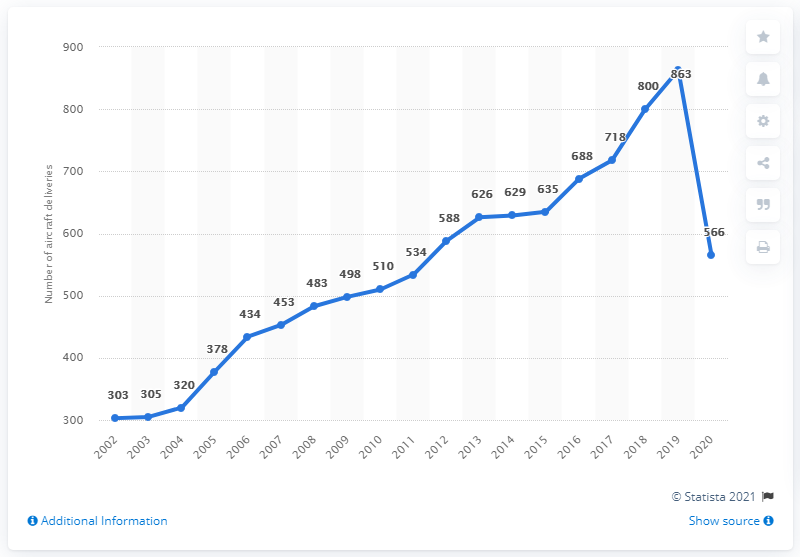Draw attention to some important aspects in this diagram. The sum of aircraft deliveries in the years 2002 and 2003 is 608. In 2020, Airbus delivered 566 aircraft to its customers worldwide. The number of Airbus aircraft in a particular year experienced a significant decline. 